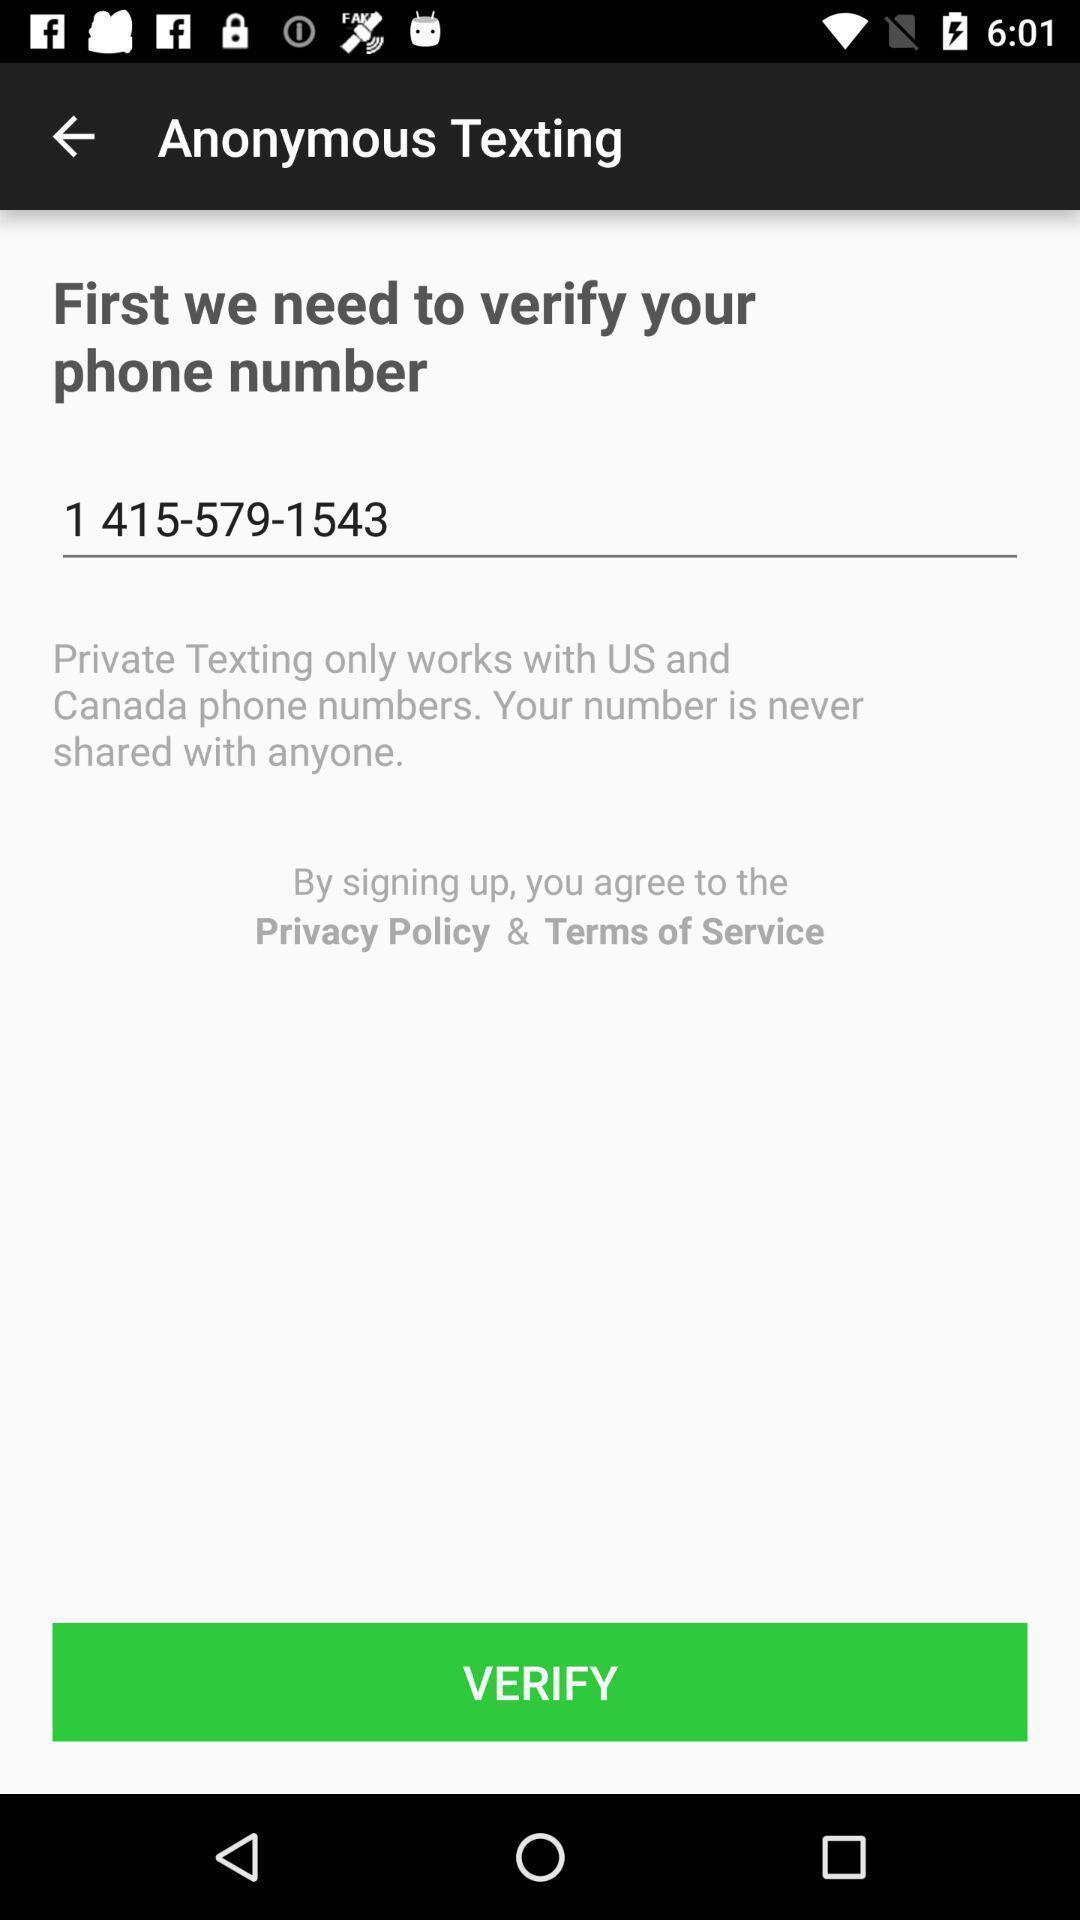Provide a detailed account of this screenshot. Screen shows to verify number in a communication app. 